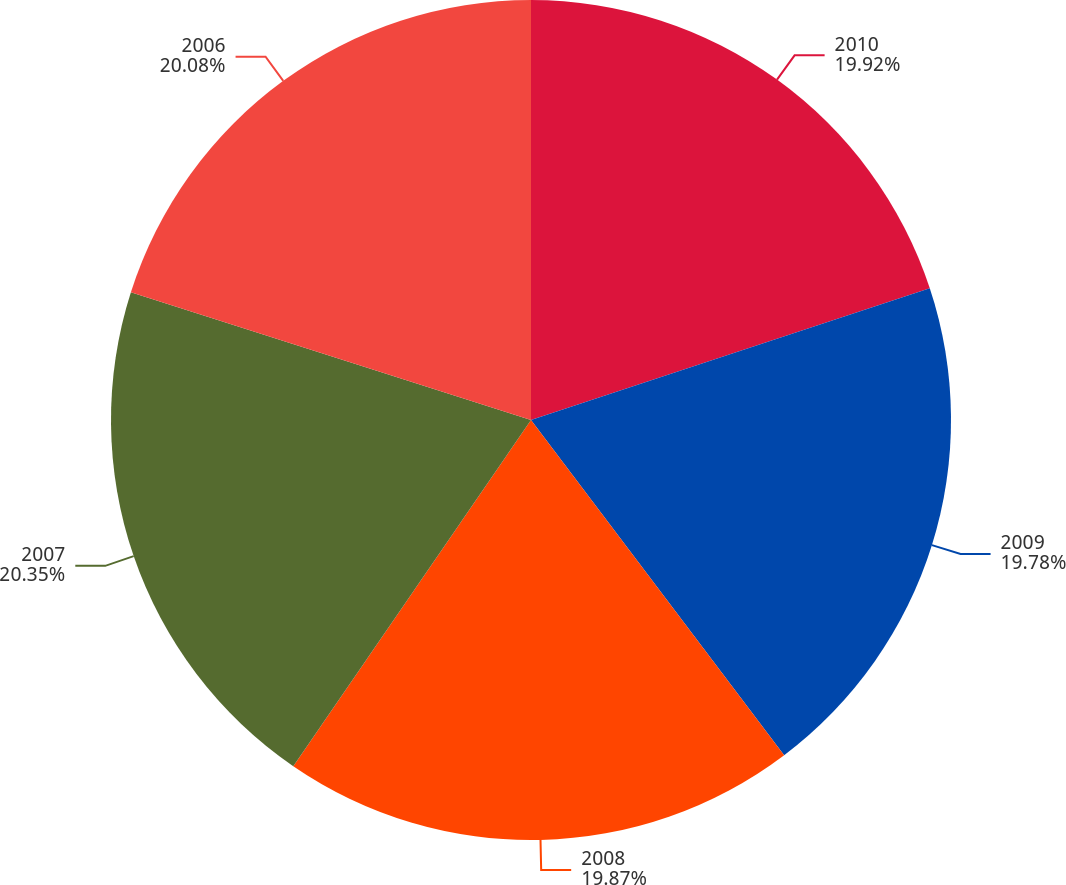Convert chart to OTSL. <chart><loc_0><loc_0><loc_500><loc_500><pie_chart><fcel>2010<fcel>2009<fcel>2008<fcel>2007<fcel>2006<nl><fcel>19.92%<fcel>19.78%<fcel>19.87%<fcel>20.34%<fcel>20.08%<nl></chart> 